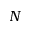<formula> <loc_0><loc_0><loc_500><loc_500>N</formula> 